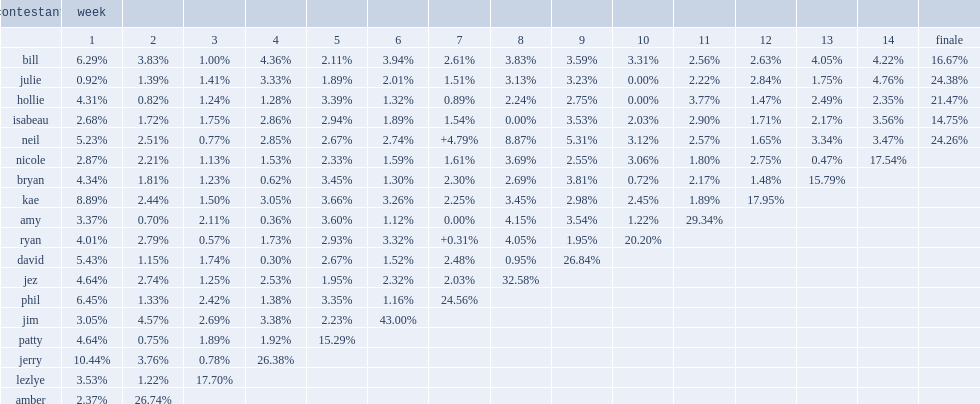Who is the biggest loser of the 3rd week with 2.69%. Jim. 